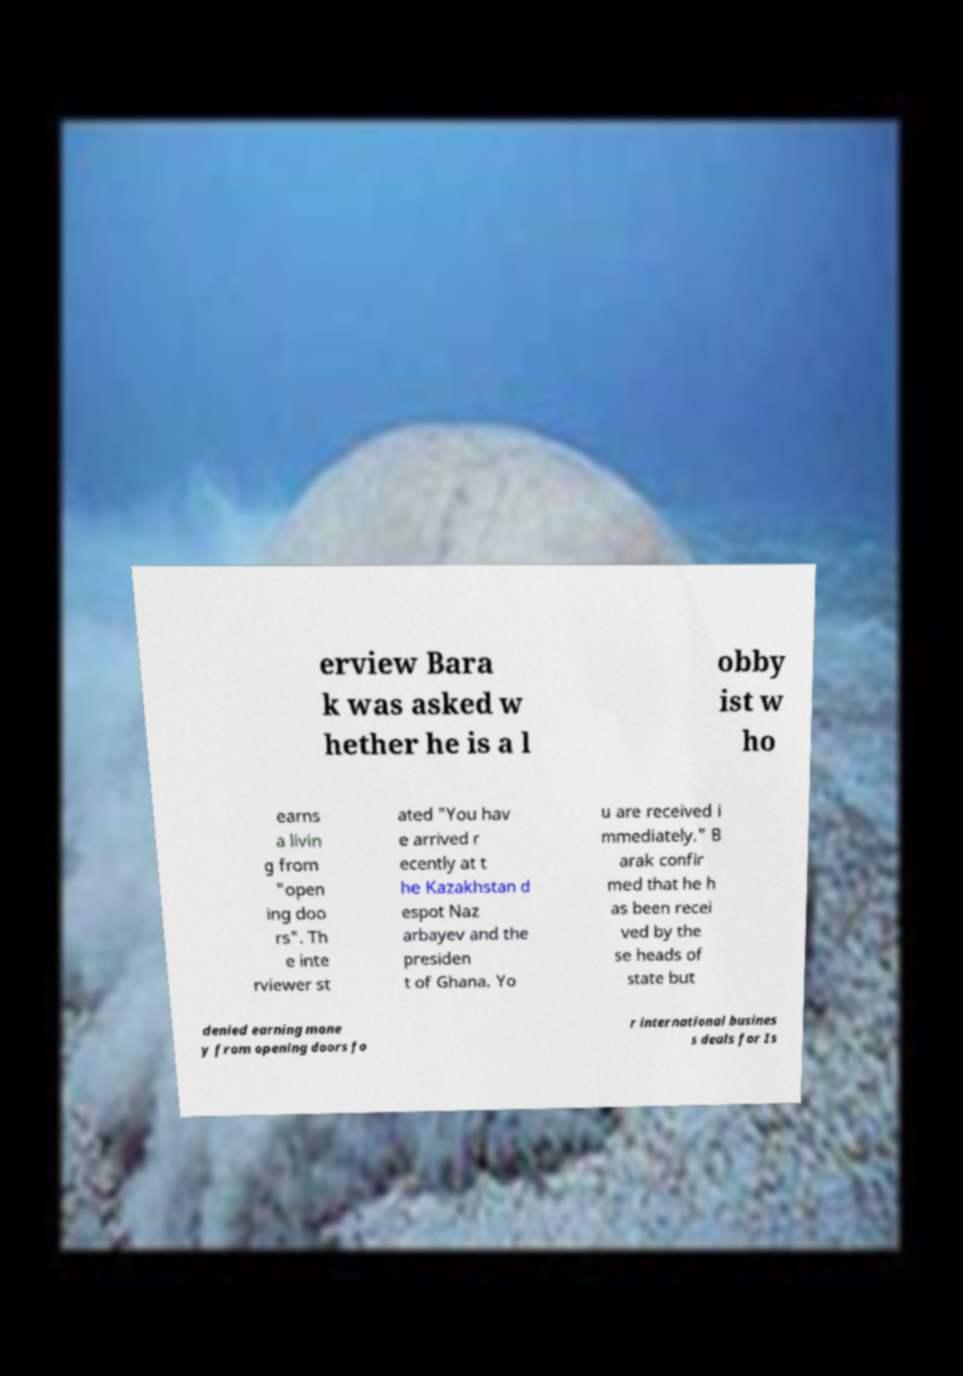There's text embedded in this image that I need extracted. Can you transcribe it verbatim? erview Bara k was asked w hether he is a l obby ist w ho earns a livin g from "open ing doo rs". Th e inte rviewer st ated "You hav e arrived r ecently at t he Kazakhstan d espot Naz arbayev and the presiden t of Ghana. Yo u are received i mmediately." B arak confir med that he h as been recei ved by the se heads of state but denied earning mone y from opening doors fo r international busines s deals for Is 